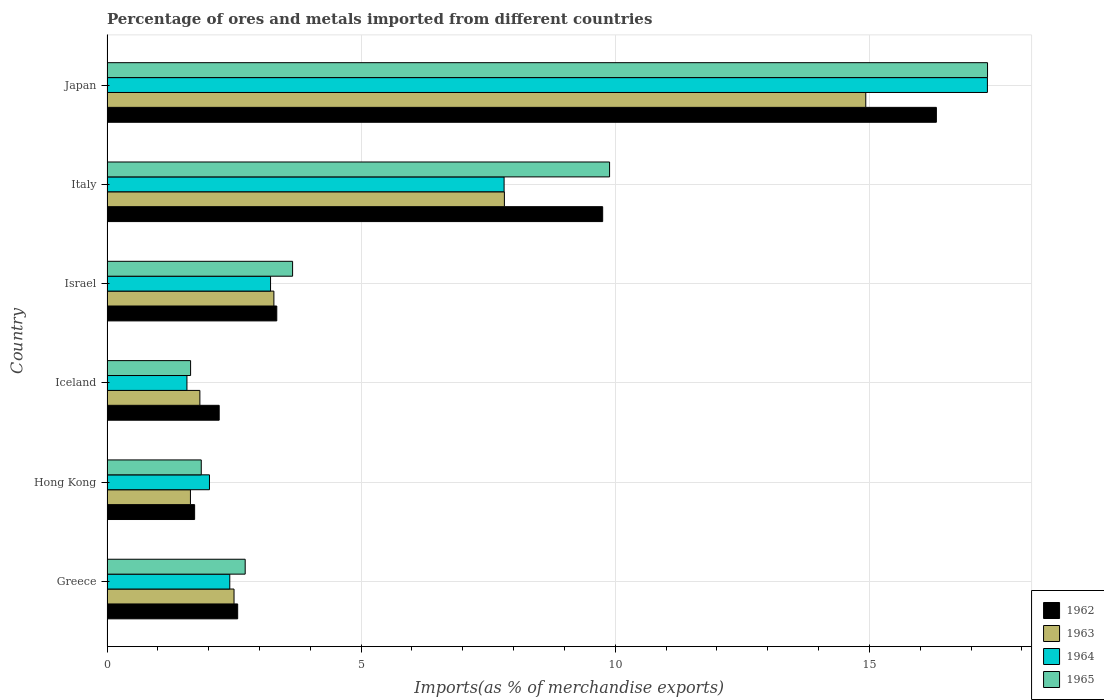Are the number of bars per tick equal to the number of legend labels?
Your answer should be compact. Yes. How many bars are there on the 3rd tick from the top?
Your response must be concise. 4. How many bars are there on the 1st tick from the bottom?
Offer a terse response. 4. What is the label of the 2nd group of bars from the top?
Your response must be concise. Italy. In how many cases, is the number of bars for a given country not equal to the number of legend labels?
Provide a succinct answer. 0. What is the percentage of imports to different countries in 1963 in Japan?
Your answer should be very brief. 14.93. Across all countries, what is the maximum percentage of imports to different countries in 1962?
Your response must be concise. 16.32. Across all countries, what is the minimum percentage of imports to different countries in 1962?
Your answer should be compact. 1.72. In which country was the percentage of imports to different countries in 1964 maximum?
Provide a succinct answer. Japan. In which country was the percentage of imports to different countries in 1965 minimum?
Keep it short and to the point. Iceland. What is the total percentage of imports to different countries in 1964 in the graph?
Your answer should be very brief. 34.35. What is the difference between the percentage of imports to different countries in 1965 in Greece and that in Iceland?
Your answer should be compact. 1.07. What is the difference between the percentage of imports to different countries in 1963 in Greece and the percentage of imports to different countries in 1965 in Hong Kong?
Your answer should be compact. 0.64. What is the average percentage of imports to different countries in 1962 per country?
Ensure brevity in your answer.  5.98. What is the difference between the percentage of imports to different countries in 1964 and percentage of imports to different countries in 1963 in Israel?
Offer a very short reply. -0.07. In how many countries, is the percentage of imports to different countries in 1965 greater than 13 %?
Ensure brevity in your answer.  1. What is the ratio of the percentage of imports to different countries in 1964 in Greece to that in Israel?
Ensure brevity in your answer.  0.75. Is the percentage of imports to different countries in 1962 in Israel less than that in Italy?
Your response must be concise. Yes. Is the difference between the percentage of imports to different countries in 1964 in Hong Kong and Japan greater than the difference between the percentage of imports to different countries in 1963 in Hong Kong and Japan?
Your response must be concise. No. What is the difference between the highest and the second highest percentage of imports to different countries in 1965?
Offer a terse response. 7.44. What is the difference between the highest and the lowest percentage of imports to different countries in 1963?
Offer a terse response. 13.29. In how many countries, is the percentage of imports to different countries in 1962 greater than the average percentage of imports to different countries in 1962 taken over all countries?
Offer a very short reply. 2. Is the sum of the percentage of imports to different countries in 1965 in Greece and Hong Kong greater than the maximum percentage of imports to different countries in 1962 across all countries?
Your response must be concise. No. What does the 1st bar from the top in Japan represents?
Ensure brevity in your answer.  1965. Is it the case that in every country, the sum of the percentage of imports to different countries in 1964 and percentage of imports to different countries in 1965 is greater than the percentage of imports to different countries in 1963?
Ensure brevity in your answer.  Yes. Are all the bars in the graph horizontal?
Your answer should be compact. Yes. How many countries are there in the graph?
Provide a succinct answer. 6. Are the values on the major ticks of X-axis written in scientific E-notation?
Make the answer very short. No. Does the graph contain any zero values?
Your answer should be very brief. No. Where does the legend appear in the graph?
Keep it short and to the point. Bottom right. How are the legend labels stacked?
Offer a very short reply. Vertical. What is the title of the graph?
Give a very brief answer. Percentage of ores and metals imported from different countries. What is the label or title of the X-axis?
Make the answer very short. Imports(as % of merchandise exports). What is the Imports(as % of merchandise exports) of 1962 in Greece?
Provide a succinct answer. 2.57. What is the Imports(as % of merchandise exports) in 1963 in Greece?
Your answer should be compact. 2.5. What is the Imports(as % of merchandise exports) in 1964 in Greece?
Make the answer very short. 2.42. What is the Imports(as % of merchandise exports) in 1965 in Greece?
Ensure brevity in your answer.  2.72. What is the Imports(as % of merchandise exports) in 1962 in Hong Kong?
Ensure brevity in your answer.  1.72. What is the Imports(as % of merchandise exports) in 1963 in Hong Kong?
Give a very brief answer. 1.64. What is the Imports(as % of merchandise exports) of 1964 in Hong Kong?
Your answer should be very brief. 2.02. What is the Imports(as % of merchandise exports) of 1965 in Hong Kong?
Keep it short and to the point. 1.85. What is the Imports(as % of merchandise exports) of 1962 in Iceland?
Your answer should be compact. 2.21. What is the Imports(as % of merchandise exports) of 1963 in Iceland?
Provide a short and direct response. 1.83. What is the Imports(as % of merchandise exports) in 1964 in Iceland?
Provide a succinct answer. 1.57. What is the Imports(as % of merchandise exports) in 1965 in Iceland?
Give a very brief answer. 1.64. What is the Imports(as % of merchandise exports) in 1962 in Israel?
Offer a terse response. 3.34. What is the Imports(as % of merchandise exports) in 1963 in Israel?
Your answer should be very brief. 3.28. What is the Imports(as % of merchandise exports) in 1964 in Israel?
Give a very brief answer. 3.22. What is the Imports(as % of merchandise exports) in 1965 in Israel?
Offer a terse response. 3.65. What is the Imports(as % of merchandise exports) in 1962 in Italy?
Your answer should be compact. 9.75. What is the Imports(as % of merchandise exports) in 1963 in Italy?
Keep it short and to the point. 7.82. What is the Imports(as % of merchandise exports) in 1964 in Italy?
Give a very brief answer. 7.81. What is the Imports(as % of merchandise exports) of 1965 in Italy?
Ensure brevity in your answer.  9.89. What is the Imports(as % of merchandise exports) in 1962 in Japan?
Give a very brief answer. 16.32. What is the Imports(as % of merchandise exports) of 1963 in Japan?
Ensure brevity in your answer.  14.93. What is the Imports(as % of merchandise exports) of 1964 in Japan?
Provide a succinct answer. 17.32. What is the Imports(as % of merchandise exports) in 1965 in Japan?
Your response must be concise. 17.32. Across all countries, what is the maximum Imports(as % of merchandise exports) of 1962?
Your response must be concise. 16.32. Across all countries, what is the maximum Imports(as % of merchandise exports) in 1963?
Offer a terse response. 14.93. Across all countries, what is the maximum Imports(as % of merchandise exports) in 1964?
Give a very brief answer. 17.32. Across all countries, what is the maximum Imports(as % of merchandise exports) of 1965?
Your answer should be compact. 17.32. Across all countries, what is the minimum Imports(as % of merchandise exports) of 1962?
Provide a short and direct response. 1.72. Across all countries, what is the minimum Imports(as % of merchandise exports) of 1963?
Keep it short and to the point. 1.64. Across all countries, what is the minimum Imports(as % of merchandise exports) of 1964?
Your answer should be compact. 1.57. Across all countries, what is the minimum Imports(as % of merchandise exports) in 1965?
Your answer should be compact. 1.64. What is the total Imports(as % of merchandise exports) of 1962 in the graph?
Give a very brief answer. 35.91. What is the total Imports(as % of merchandise exports) of 1963 in the graph?
Your answer should be very brief. 32. What is the total Imports(as % of merchandise exports) in 1964 in the graph?
Offer a very short reply. 34.35. What is the total Imports(as % of merchandise exports) of 1965 in the graph?
Provide a short and direct response. 37.08. What is the difference between the Imports(as % of merchandise exports) of 1962 in Greece and that in Hong Kong?
Give a very brief answer. 0.85. What is the difference between the Imports(as % of merchandise exports) in 1963 in Greece and that in Hong Kong?
Keep it short and to the point. 0.86. What is the difference between the Imports(as % of merchandise exports) of 1964 in Greece and that in Hong Kong?
Your answer should be compact. 0.4. What is the difference between the Imports(as % of merchandise exports) in 1965 in Greece and that in Hong Kong?
Your response must be concise. 0.86. What is the difference between the Imports(as % of merchandise exports) in 1962 in Greece and that in Iceland?
Give a very brief answer. 0.36. What is the difference between the Imports(as % of merchandise exports) of 1963 in Greece and that in Iceland?
Offer a very short reply. 0.67. What is the difference between the Imports(as % of merchandise exports) in 1964 in Greece and that in Iceland?
Provide a succinct answer. 0.84. What is the difference between the Imports(as % of merchandise exports) of 1965 in Greece and that in Iceland?
Your answer should be compact. 1.07. What is the difference between the Imports(as % of merchandise exports) of 1962 in Greece and that in Israel?
Offer a very short reply. -0.77. What is the difference between the Imports(as % of merchandise exports) of 1963 in Greece and that in Israel?
Offer a terse response. -0.78. What is the difference between the Imports(as % of merchandise exports) of 1964 in Greece and that in Israel?
Offer a very short reply. -0.8. What is the difference between the Imports(as % of merchandise exports) in 1965 in Greece and that in Israel?
Ensure brevity in your answer.  -0.93. What is the difference between the Imports(as % of merchandise exports) in 1962 in Greece and that in Italy?
Make the answer very short. -7.18. What is the difference between the Imports(as % of merchandise exports) of 1963 in Greece and that in Italy?
Offer a terse response. -5.32. What is the difference between the Imports(as % of merchandise exports) in 1964 in Greece and that in Italy?
Your answer should be compact. -5.4. What is the difference between the Imports(as % of merchandise exports) in 1965 in Greece and that in Italy?
Provide a succinct answer. -7.17. What is the difference between the Imports(as % of merchandise exports) of 1962 in Greece and that in Japan?
Give a very brief answer. -13.75. What is the difference between the Imports(as % of merchandise exports) in 1963 in Greece and that in Japan?
Your response must be concise. -12.43. What is the difference between the Imports(as % of merchandise exports) in 1964 in Greece and that in Japan?
Your answer should be compact. -14.9. What is the difference between the Imports(as % of merchandise exports) of 1965 in Greece and that in Japan?
Your answer should be compact. -14.6. What is the difference between the Imports(as % of merchandise exports) of 1962 in Hong Kong and that in Iceland?
Your answer should be compact. -0.48. What is the difference between the Imports(as % of merchandise exports) in 1963 in Hong Kong and that in Iceland?
Offer a very short reply. -0.19. What is the difference between the Imports(as % of merchandise exports) of 1964 in Hong Kong and that in Iceland?
Your response must be concise. 0.44. What is the difference between the Imports(as % of merchandise exports) in 1965 in Hong Kong and that in Iceland?
Your answer should be compact. 0.21. What is the difference between the Imports(as % of merchandise exports) of 1962 in Hong Kong and that in Israel?
Your response must be concise. -1.62. What is the difference between the Imports(as % of merchandise exports) of 1963 in Hong Kong and that in Israel?
Provide a succinct answer. -1.64. What is the difference between the Imports(as % of merchandise exports) of 1964 in Hong Kong and that in Israel?
Your answer should be compact. -1.2. What is the difference between the Imports(as % of merchandise exports) in 1965 in Hong Kong and that in Israel?
Make the answer very short. -1.8. What is the difference between the Imports(as % of merchandise exports) of 1962 in Hong Kong and that in Italy?
Keep it short and to the point. -8.03. What is the difference between the Imports(as % of merchandise exports) of 1963 in Hong Kong and that in Italy?
Provide a succinct answer. -6.18. What is the difference between the Imports(as % of merchandise exports) of 1964 in Hong Kong and that in Italy?
Your response must be concise. -5.8. What is the difference between the Imports(as % of merchandise exports) of 1965 in Hong Kong and that in Italy?
Ensure brevity in your answer.  -8.03. What is the difference between the Imports(as % of merchandise exports) in 1962 in Hong Kong and that in Japan?
Your response must be concise. -14.59. What is the difference between the Imports(as % of merchandise exports) in 1963 in Hong Kong and that in Japan?
Offer a terse response. -13.29. What is the difference between the Imports(as % of merchandise exports) of 1964 in Hong Kong and that in Japan?
Your answer should be very brief. -15.3. What is the difference between the Imports(as % of merchandise exports) of 1965 in Hong Kong and that in Japan?
Your answer should be compact. -15.47. What is the difference between the Imports(as % of merchandise exports) of 1962 in Iceland and that in Israel?
Give a very brief answer. -1.13. What is the difference between the Imports(as % of merchandise exports) in 1963 in Iceland and that in Israel?
Your response must be concise. -1.46. What is the difference between the Imports(as % of merchandise exports) of 1964 in Iceland and that in Israel?
Offer a very short reply. -1.65. What is the difference between the Imports(as % of merchandise exports) of 1965 in Iceland and that in Israel?
Give a very brief answer. -2.01. What is the difference between the Imports(as % of merchandise exports) of 1962 in Iceland and that in Italy?
Your response must be concise. -7.54. What is the difference between the Imports(as % of merchandise exports) of 1963 in Iceland and that in Italy?
Make the answer very short. -5.99. What is the difference between the Imports(as % of merchandise exports) in 1964 in Iceland and that in Italy?
Make the answer very short. -6.24. What is the difference between the Imports(as % of merchandise exports) in 1965 in Iceland and that in Italy?
Your response must be concise. -8.24. What is the difference between the Imports(as % of merchandise exports) in 1962 in Iceland and that in Japan?
Give a very brief answer. -14.11. What is the difference between the Imports(as % of merchandise exports) of 1963 in Iceland and that in Japan?
Provide a succinct answer. -13.1. What is the difference between the Imports(as % of merchandise exports) of 1964 in Iceland and that in Japan?
Your answer should be very brief. -15.75. What is the difference between the Imports(as % of merchandise exports) of 1965 in Iceland and that in Japan?
Make the answer very short. -15.68. What is the difference between the Imports(as % of merchandise exports) of 1962 in Israel and that in Italy?
Make the answer very short. -6.41. What is the difference between the Imports(as % of merchandise exports) in 1963 in Israel and that in Italy?
Your response must be concise. -4.53. What is the difference between the Imports(as % of merchandise exports) of 1964 in Israel and that in Italy?
Your response must be concise. -4.59. What is the difference between the Imports(as % of merchandise exports) of 1965 in Israel and that in Italy?
Keep it short and to the point. -6.24. What is the difference between the Imports(as % of merchandise exports) of 1962 in Israel and that in Japan?
Give a very brief answer. -12.98. What is the difference between the Imports(as % of merchandise exports) in 1963 in Israel and that in Japan?
Your answer should be very brief. -11.64. What is the difference between the Imports(as % of merchandise exports) in 1964 in Israel and that in Japan?
Your response must be concise. -14.1. What is the difference between the Imports(as % of merchandise exports) of 1965 in Israel and that in Japan?
Give a very brief answer. -13.67. What is the difference between the Imports(as % of merchandise exports) of 1962 in Italy and that in Japan?
Make the answer very short. -6.57. What is the difference between the Imports(as % of merchandise exports) in 1963 in Italy and that in Japan?
Make the answer very short. -7.11. What is the difference between the Imports(as % of merchandise exports) of 1964 in Italy and that in Japan?
Offer a very short reply. -9.51. What is the difference between the Imports(as % of merchandise exports) in 1965 in Italy and that in Japan?
Ensure brevity in your answer.  -7.44. What is the difference between the Imports(as % of merchandise exports) in 1962 in Greece and the Imports(as % of merchandise exports) in 1963 in Hong Kong?
Your answer should be compact. 0.93. What is the difference between the Imports(as % of merchandise exports) in 1962 in Greece and the Imports(as % of merchandise exports) in 1964 in Hong Kong?
Provide a short and direct response. 0.55. What is the difference between the Imports(as % of merchandise exports) in 1962 in Greece and the Imports(as % of merchandise exports) in 1965 in Hong Kong?
Offer a terse response. 0.72. What is the difference between the Imports(as % of merchandise exports) in 1963 in Greece and the Imports(as % of merchandise exports) in 1964 in Hong Kong?
Provide a succinct answer. 0.48. What is the difference between the Imports(as % of merchandise exports) in 1963 in Greece and the Imports(as % of merchandise exports) in 1965 in Hong Kong?
Offer a very short reply. 0.64. What is the difference between the Imports(as % of merchandise exports) in 1964 in Greece and the Imports(as % of merchandise exports) in 1965 in Hong Kong?
Offer a very short reply. 0.56. What is the difference between the Imports(as % of merchandise exports) in 1962 in Greece and the Imports(as % of merchandise exports) in 1963 in Iceland?
Provide a succinct answer. 0.74. What is the difference between the Imports(as % of merchandise exports) of 1962 in Greece and the Imports(as % of merchandise exports) of 1965 in Iceland?
Keep it short and to the point. 0.93. What is the difference between the Imports(as % of merchandise exports) in 1963 in Greece and the Imports(as % of merchandise exports) in 1964 in Iceland?
Provide a short and direct response. 0.93. What is the difference between the Imports(as % of merchandise exports) of 1963 in Greece and the Imports(as % of merchandise exports) of 1965 in Iceland?
Provide a succinct answer. 0.85. What is the difference between the Imports(as % of merchandise exports) of 1964 in Greece and the Imports(as % of merchandise exports) of 1965 in Iceland?
Offer a very short reply. 0.77. What is the difference between the Imports(as % of merchandise exports) of 1962 in Greece and the Imports(as % of merchandise exports) of 1963 in Israel?
Provide a short and direct response. -0.71. What is the difference between the Imports(as % of merchandise exports) of 1962 in Greece and the Imports(as % of merchandise exports) of 1964 in Israel?
Provide a succinct answer. -0.65. What is the difference between the Imports(as % of merchandise exports) in 1962 in Greece and the Imports(as % of merchandise exports) in 1965 in Israel?
Provide a succinct answer. -1.08. What is the difference between the Imports(as % of merchandise exports) of 1963 in Greece and the Imports(as % of merchandise exports) of 1964 in Israel?
Provide a short and direct response. -0.72. What is the difference between the Imports(as % of merchandise exports) of 1963 in Greece and the Imports(as % of merchandise exports) of 1965 in Israel?
Provide a short and direct response. -1.15. What is the difference between the Imports(as % of merchandise exports) of 1964 in Greece and the Imports(as % of merchandise exports) of 1965 in Israel?
Your answer should be very brief. -1.24. What is the difference between the Imports(as % of merchandise exports) of 1962 in Greece and the Imports(as % of merchandise exports) of 1963 in Italy?
Make the answer very short. -5.25. What is the difference between the Imports(as % of merchandise exports) of 1962 in Greece and the Imports(as % of merchandise exports) of 1964 in Italy?
Your answer should be very brief. -5.24. What is the difference between the Imports(as % of merchandise exports) in 1962 in Greece and the Imports(as % of merchandise exports) in 1965 in Italy?
Give a very brief answer. -7.32. What is the difference between the Imports(as % of merchandise exports) in 1963 in Greece and the Imports(as % of merchandise exports) in 1964 in Italy?
Keep it short and to the point. -5.31. What is the difference between the Imports(as % of merchandise exports) of 1963 in Greece and the Imports(as % of merchandise exports) of 1965 in Italy?
Keep it short and to the point. -7.39. What is the difference between the Imports(as % of merchandise exports) in 1964 in Greece and the Imports(as % of merchandise exports) in 1965 in Italy?
Ensure brevity in your answer.  -7.47. What is the difference between the Imports(as % of merchandise exports) in 1962 in Greece and the Imports(as % of merchandise exports) in 1963 in Japan?
Provide a succinct answer. -12.36. What is the difference between the Imports(as % of merchandise exports) in 1962 in Greece and the Imports(as % of merchandise exports) in 1964 in Japan?
Provide a short and direct response. -14.75. What is the difference between the Imports(as % of merchandise exports) of 1962 in Greece and the Imports(as % of merchandise exports) of 1965 in Japan?
Keep it short and to the point. -14.75. What is the difference between the Imports(as % of merchandise exports) of 1963 in Greece and the Imports(as % of merchandise exports) of 1964 in Japan?
Make the answer very short. -14.82. What is the difference between the Imports(as % of merchandise exports) of 1963 in Greece and the Imports(as % of merchandise exports) of 1965 in Japan?
Make the answer very short. -14.82. What is the difference between the Imports(as % of merchandise exports) in 1964 in Greece and the Imports(as % of merchandise exports) in 1965 in Japan?
Keep it short and to the point. -14.91. What is the difference between the Imports(as % of merchandise exports) of 1962 in Hong Kong and the Imports(as % of merchandise exports) of 1963 in Iceland?
Your answer should be very brief. -0.1. What is the difference between the Imports(as % of merchandise exports) of 1962 in Hong Kong and the Imports(as % of merchandise exports) of 1964 in Iceland?
Your answer should be compact. 0.15. What is the difference between the Imports(as % of merchandise exports) in 1962 in Hong Kong and the Imports(as % of merchandise exports) in 1965 in Iceland?
Ensure brevity in your answer.  0.08. What is the difference between the Imports(as % of merchandise exports) of 1963 in Hong Kong and the Imports(as % of merchandise exports) of 1964 in Iceland?
Your response must be concise. 0.07. What is the difference between the Imports(as % of merchandise exports) in 1963 in Hong Kong and the Imports(as % of merchandise exports) in 1965 in Iceland?
Offer a terse response. -0. What is the difference between the Imports(as % of merchandise exports) in 1964 in Hong Kong and the Imports(as % of merchandise exports) in 1965 in Iceland?
Ensure brevity in your answer.  0.37. What is the difference between the Imports(as % of merchandise exports) in 1962 in Hong Kong and the Imports(as % of merchandise exports) in 1963 in Israel?
Provide a short and direct response. -1.56. What is the difference between the Imports(as % of merchandise exports) of 1962 in Hong Kong and the Imports(as % of merchandise exports) of 1964 in Israel?
Offer a very short reply. -1.49. What is the difference between the Imports(as % of merchandise exports) of 1962 in Hong Kong and the Imports(as % of merchandise exports) of 1965 in Israel?
Make the answer very short. -1.93. What is the difference between the Imports(as % of merchandise exports) of 1963 in Hong Kong and the Imports(as % of merchandise exports) of 1964 in Israel?
Provide a succinct answer. -1.58. What is the difference between the Imports(as % of merchandise exports) of 1963 in Hong Kong and the Imports(as % of merchandise exports) of 1965 in Israel?
Offer a very short reply. -2.01. What is the difference between the Imports(as % of merchandise exports) in 1964 in Hong Kong and the Imports(as % of merchandise exports) in 1965 in Israel?
Your response must be concise. -1.64. What is the difference between the Imports(as % of merchandise exports) of 1962 in Hong Kong and the Imports(as % of merchandise exports) of 1963 in Italy?
Provide a short and direct response. -6.09. What is the difference between the Imports(as % of merchandise exports) in 1962 in Hong Kong and the Imports(as % of merchandise exports) in 1964 in Italy?
Your answer should be compact. -6.09. What is the difference between the Imports(as % of merchandise exports) of 1962 in Hong Kong and the Imports(as % of merchandise exports) of 1965 in Italy?
Your response must be concise. -8.16. What is the difference between the Imports(as % of merchandise exports) of 1963 in Hong Kong and the Imports(as % of merchandise exports) of 1964 in Italy?
Your answer should be compact. -6.17. What is the difference between the Imports(as % of merchandise exports) of 1963 in Hong Kong and the Imports(as % of merchandise exports) of 1965 in Italy?
Provide a succinct answer. -8.25. What is the difference between the Imports(as % of merchandise exports) in 1964 in Hong Kong and the Imports(as % of merchandise exports) in 1965 in Italy?
Your answer should be compact. -7.87. What is the difference between the Imports(as % of merchandise exports) of 1962 in Hong Kong and the Imports(as % of merchandise exports) of 1963 in Japan?
Provide a succinct answer. -13.2. What is the difference between the Imports(as % of merchandise exports) of 1962 in Hong Kong and the Imports(as % of merchandise exports) of 1964 in Japan?
Give a very brief answer. -15.6. What is the difference between the Imports(as % of merchandise exports) of 1962 in Hong Kong and the Imports(as % of merchandise exports) of 1965 in Japan?
Give a very brief answer. -15.6. What is the difference between the Imports(as % of merchandise exports) of 1963 in Hong Kong and the Imports(as % of merchandise exports) of 1964 in Japan?
Your response must be concise. -15.68. What is the difference between the Imports(as % of merchandise exports) of 1963 in Hong Kong and the Imports(as % of merchandise exports) of 1965 in Japan?
Your answer should be very brief. -15.68. What is the difference between the Imports(as % of merchandise exports) of 1964 in Hong Kong and the Imports(as % of merchandise exports) of 1965 in Japan?
Your answer should be very brief. -15.31. What is the difference between the Imports(as % of merchandise exports) of 1962 in Iceland and the Imports(as % of merchandise exports) of 1963 in Israel?
Your answer should be compact. -1.08. What is the difference between the Imports(as % of merchandise exports) of 1962 in Iceland and the Imports(as % of merchandise exports) of 1964 in Israel?
Your answer should be very brief. -1.01. What is the difference between the Imports(as % of merchandise exports) of 1962 in Iceland and the Imports(as % of merchandise exports) of 1965 in Israel?
Make the answer very short. -1.44. What is the difference between the Imports(as % of merchandise exports) in 1963 in Iceland and the Imports(as % of merchandise exports) in 1964 in Israel?
Your response must be concise. -1.39. What is the difference between the Imports(as % of merchandise exports) of 1963 in Iceland and the Imports(as % of merchandise exports) of 1965 in Israel?
Keep it short and to the point. -1.82. What is the difference between the Imports(as % of merchandise exports) in 1964 in Iceland and the Imports(as % of merchandise exports) in 1965 in Israel?
Ensure brevity in your answer.  -2.08. What is the difference between the Imports(as % of merchandise exports) in 1962 in Iceland and the Imports(as % of merchandise exports) in 1963 in Italy?
Offer a very short reply. -5.61. What is the difference between the Imports(as % of merchandise exports) in 1962 in Iceland and the Imports(as % of merchandise exports) in 1964 in Italy?
Provide a succinct answer. -5.61. What is the difference between the Imports(as % of merchandise exports) in 1962 in Iceland and the Imports(as % of merchandise exports) in 1965 in Italy?
Provide a short and direct response. -7.68. What is the difference between the Imports(as % of merchandise exports) of 1963 in Iceland and the Imports(as % of merchandise exports) of 1964 in Italy?
Your response must be concise. -5.98. What is the difference between the Imports(as % of merchandise exports) in 1963 in Iceland and the Imports(as % of merchandise exports) in 1965 in Italy?
Keep it short and to the point. -8.06. What is the difference between the Imports(as % of merchandise exports) of 1964 in Iceland and the Imports(as % of merchandise exports) of 1965 in Italy?
Your answer should be very brief. -8.31. What is the difference between the Imports(as % of merchandise exports) of 1962 in Iceland and the Imports(as % of merchandise exports) of 1963 in Japan?
Give a very brief answer. -12.72. What is the difference between the Imports(as % of merchandise exports) of 1962 in Iceland and the Imports(as % of merchandise exports) of 1964 in Japan?
Your answer should be very brief. -15.11. What is the difference between the Imports(as % of merchandise exports) of 1962 in Iceland and the Imports(as % of merchandise exports) of 1965 in Japan?
Your answer should be compact. -15.12. What is the difference between the Imports(as % of merchandise exports) in 1963 in Iceland and the Imports(as % of merchandise exports) in 1964 in Japan?
Offer a very short reply. -15.49. What is the difference between the Imports(as % of merchandise exports) in 1963 in Iceland and the Imports(as % of merchandise exports) in 1965 in Japan?
Your answer should be very brief. -15.5. What is the difference between the Imports(as % of merchandise exports) of 1964 in Iceland and the Imports(as % of merchandise exports) of 1965 in Japan?
Ensure brevity in your answer.  -15.75. What is the difference between the Imports(as % of merchandise exports) in 1962 in Israel and the Imports(as % of merchandise exports) in 1963 in Italy?
Make the answer very short. -4.48. What is the difference between the Imports(as % of merchandise exports) in 1962 in Israel and the Imports(as % of merchandise exports) in 1964 in Italy?
Give a very brief answer. -4.47. What is the difference between the Imports(as % of merchandise exports) of 1962 in Israel and the Imports(as % of merchandise exports) of 1965 in Italy?
Provide a short and direct response. -6.55. What is the difference between the Imports(as % of merchandise exports) in 1963 in Israel and the Imports(as % of merchandise exports) in 1964 in Italy?
Give a very brief answer. -4.53. What is the difference between the Imports(as % of merchandise exports) of 1963 in Israel and the Imports(as % of merchandise exports) of 1965 in Italy?
Offer a terse response. -6.6. What is the difference between the Imports(as % of merchandise exports) of 1964 in Israel and the Imports(as % of merchandise exports) of 1965 in Italy?
Your answer should be compact. -6.67. What is the difference between the Imports(as % of merchandise exports) of 1962 in Israel and the Imports(as % of merchandise exports) of 1963 in Japan?
Offer a very short reply. -11.59. What is the difference between the Imports(as % of merchandise exports) of 1962 in Israel and the Imports(as % of merchandise exports) of 1964 in Japan?
Ensure brevity in your answer.  -13.98. What is the difference between the Imports(as % of merchandise exports) of 1962 in Israel and the Imports(as % of merchandise exports) of 1965 in Japan?
Provide a short and direct response. -13.98. What is the difference between the Imports(as % of merchandise exports) in 1963 in Israel and the Imports(as % of merchandise exports) in 1964 in Japan?
Your answer should be compact. -14.04. What is the difference between the Imports(as % of merchandise exports) in 1963 in Israel and the Imports(as % of merchandise exports) in 1965 in Japan?
Offer a very short reply. -14.04. What is the difference between the Imports(as % of merchandise exports) of 1964 in Israel and the Imports(as % of merchandise exports) of 1965 in Japan?
Keep it short and to the point. -14.11. What is the difference between the Imports(as % of merchandise exports) in 1962 in Italy and the Imports(as % of merchandise exports) in 1963 in Japan?
Your answer should be compact. -5.18. What is the difference between the Imports(as % of merchandise exports) in 1962 in Italy and the Imports(as % of merchandise exports) in 1964 in Japan?
Your answer should be compact. -7.57. What is the difference between the Imports(as % of merchandise exports) in 1962 in Italy and the Imports(as % of merchandise exports) in 1965 in Japan?
Your response must be concise. -7.57. What is the difference between the Imports(as % of merchandise exports) of 1963 in Italy and the Imports(as % of merchandise exports) of 1964 in Japan?
Keep it short and to the point. -9.5. What is the difference between the Imports(as % of merchandise exports) in 1963 in Italy and the Imports(as % of merchandise exports) in 1965 in Japan?
Make the answer very short. -9.51. What is the difference between the Imports(as % of merchandise exports) of 1964 in Italy and the Imports(as % of merchandise exports) of 1965 in Japan?
Give a very brief answer. -9.51. What is the average Imports(as % of merchandise exports) of 1962 per country?
Give a very brief answer. 5.98. What is the average Imports(as % of merchandise exports) of 1963 per country?
Provide a succinct answer. 5.33. What is the average Imports(as % of merchandise exports) of 1964 per country?
Your response must be concise. 5.73. What is the average Imports(as % of merchandise exports) of 1965 per country?
Provide a succinct answer. 6.18. What is the difference between the Imports(as % of merchandise exports) of 1962 and Imports(as % of merchandise exports) of 1963 in Greece?
Ensure brevity in your answer.  0.07. What is the difference between the Imports(as % of merchandise exports) in 1962 and Imports(as % of merchandise exports) in 1964 in Greece?
Offer a very short reply. 0.16. What is the difference between the Imports(as % of merchandise exports) in 1962 and Imports(as % of merchandise exports) in 1965 in Greece?
Ensure brevity in your answer.  -0.15. What is the difference between the Imports(as % of merchandise exports) in 1963 and Imports(as % of merchandise exports) in 1964 in Greece?
Your answer should be compact. 0.08. What is the difference between the Imports(as % of merchandise exports) in 1963 and Imports(as % of merchandise exports) in 1965 in Greece?
Your response must be concise. -0.22. What is the difference between the Imports(as % of merchandise exports) of 1964 and Imports(as % of merchandise exports) of 1965 in Greece?
Your response must be concise. -0.3. What is the difference between the Imports(as % of merchandise exports) in 1962 and Imports(as % of merchandise exports) in 1963 in Hong Kong?
Offer a terse response. 0.08. What is the difference between the Imports(as % of merchandise exports) in 1962 and Imports(as % of merchandise exports) in 1964 in Hong Kong?
Make the answer very short. -0.29. What is the difference between the Imports(as % of merchandise exports) in 1962 and Imports(as % of merchandise exports) in 1965 in Hong Kong?
Offer a very short reply. -0.13. What is the difference between the Imports(as % of merchandise exports) in 1963 and Imports(as % of merchandise exports) in 1964 in Hong Kong?
Provide a short and direct response. -0.37. What is the difference between the Imports(as % of merchandise exports) in 1963 and Imports(as % of merchandise exports) in 1965 in Hong Kong?
Your response must be concise. -0.21. What is the difference between the Imports(as % of merchandise exports) of 1964 and Imports(as % of merchandise exports) of 1965 in Hong Kong?
Give a very brief answer. 0.16. What is the difference between the Imports(as % of merchandise exports) of 1962 and Imports(as % of merchandise exports) of 1963 in Iceland?
Give a very brief answer. 0.38. What is the difference between the Imports(as % of merchandise exports) of 1962 and Imports(as % of merchandise exports) of 1964 in Iceland?
Keep it short and to the point. 0.63. What is the difference between the Imports(as % of merchandise exports) of 1962 and Imports(as % of merchandise exports) of 1965 in Iceland?
Your answer should be compact. 0.56. What is the difference between the Imports(as % of merchandise exports) of 1963 and Imports(as % of merchandise exports) of 1964 in Iceland?
Offer a terse response. 0.25. What is the difference between the Imports(as % of merchandise exports) of 1963 and Imports(as % of merchandise exports) of 1965 in Iceland?
Ensure brevity in your answer.  0.18. What is the difference between the Imports(as % of merchandise exports) in 1964 and Imports(as % of merchandise exports) in 1965 in Iceland?
Your answer should be compact. -0.07. What is the difference between the Imports(as % of merchandise exports) in 1962 and Imports(as % of merchandise exports) in 1963 in Israel?
Keep it short and to the point. 0.06. What is the difference between the Imports(as % of merchandise exports) in 1962 and Imports(as % of merchandise exports) in 1964 in Israel?
Ensure brevity in your answer.  0.12. What is the difference between the Imports(as % of merchandise exports) in 1962 and Imports(as % of merchandise exports) in 1965 in Israel?
Give a very brief answer. -0.31. What is the difference between the Imports(as % of merchandise exports) of 1963 and Imports(as % of merchandise exports) of 1964 in Israel?
Give a very brief answer. 0.07. What is the difference between the Imports(as % of merchandise exports) in 1963 and Imports(as % of merchandise exports) in 1965 in Israel?
Your answer should be compact. -0.37. What is the difference between the Imports(as % of merchandise exports) of 1964 and Imports(as % of merchandise exports) of 1965 in Israel?
Offer a very short reply. -0.43. What is the difference between the Imports(as % of merchandise exports) of 1962 and Imports(as % of merchandise exports) of 1963 in Italy?
Ensure brevity in your answer.  1.93. What is the difference between the Imports(as % of merchandise exports) in 1962 and Imports(as % of merchandise exports) in 1964 in Italy?
Offer a terse response. 1.94. What is the difference between the Imports(as % of merchandise exports) of 1962 and Imports(as % of merchandise exports) of 1965 in Italy?
Keep it short and to the point. -0.14. What is the difference between the Imports(as % of merchandise exports) of 1963 and Imports(as % of merchandise exports) of 1964 in Italy?
Ensure brevity in your answer.  0.01. What is the difference between the Imports(as % of merchandise exports) of 1963 and Imports(as % of merchandise exports) of 1965 in Italy?
Your response must be concise. -2.07. What is the difference between the Imports(as % of merchandise exports) in 1964 and Imports(as % of merchandise exports) in 1965 in Italy?
Provide a short and direct response. -2.08. What is the difference between the Imports(as % of merchandise exports) in 1962 and Imports(as % of merchandise exports) in 1963 in Japan?
Your response must be concise. 1.39. What is the difference between the Imports(as % of merchandise exports) in 1962 and Imports(as % of merchandise exports) in 1964 in Japan?
Ensure brevity in your answer.  -1. What is the difference between the Imports(as % of merchandise exports) of 1962 and Imports(as % of merchandise exports) of 1965 in Japan?
Make the answer very short. -1.01. What is the difference between the Imports(as % of merchandise exports) in 1963 and Imports(as % of merchandise exports) in 1964 in Japan?
Ensure brevity in your answer.  -2.39. What is the difference between the Imports(as % of merchandise exports) of 1963 and Imports(as % of merchandise exports) of 1965 in Japan?
Make the answer very short. -2.4. What is the difference between the Imports(as % of merchandise exports) of 1964 and Imports(as % of merchandise exports) of 1965 in Japan?
Your answer should be compact. -0. What is the ratio of the Imports(as % of merchandise exports) of 1962 in Greece to that in Hong Kong?
Offer a terse response. 1.49. What is the ratio of the Imports(as % of merchandise exports) in 1963 in Greece to that in Hong Kong?
Offer a terse response. 1.52. What is the ratio of the Imports(as % of merchandise exports) in 1964 in Greece to that in Hong Kong?
Your response must be concise. 1.2. What is the ratio of the Imports(as % of merchandise exports) of 1965 in Greece to that in Hong Kong?
Your answer should be very brief. 1.47. What is the ratio of the Imports(as % of merchandise exports) in 1962 in Greece to that in Iceland?
Ensure brevity in your answer.  1.16. What is the ratio of the Imports(as % of merchandise exports) in 1963 in Greece to that in Iceland?
Your answer should be very brief. 1.37. What is the ratio of the Imports(as % of merchandise exports) of 1964 in Greece to that in Iceland?
Your response must be concise. 1.54. What is the ratio of the Imports(as % of merchandise exports) in 1965 in Greece to that in Iceland?
Provide a short and direct response. 1.65. What is the ratio of the Imports(as % of merchandise exports) in 1962 in Greece to that in Israel?
Give a very brief answer. 0.77. What is the ratio of the Imports(as % of merchandise exports) in 1963 in Greece to that in Israel?
Your response must be concise. 0.76. What is the ratio of the Imports(as % of merchandise exports) in 1964 in Greece to that in Israel?
Provide a succinct answer. 0.75. What is the ratio of the Imports(as % of merchandise exports) in 1965 in Greece to that in Israel?
Provide a succinct answer. 0.74. What is the ratio of the Imports(as % of merchandise exports) in 1962 in Greece to that in Italy?
Give a very brief answer. 0.26. What is the ratio of the Imports(as % of merchandise exports) of 1963 in Greece to that in Italy?
Give a very brief answer. 0.32. What is the ratio of the Imports(as % of merchandise exports) of 1964 in Greece to that in Italy?
Provide a short and direct response. 0.31. What is the ratio of the Imports(as % of merchandise exports) in 1965 in Greece to that in Italy?
Your answer should be compact. 0.28. What is the ratio of the Imports(as % of merchandise exports) of 1962 in Greece to that in Japan?
Provide a succinct answer. 0.16. What is the ratio of the Imports(as % of merchandise exports) of 1963 in Greece to that in Japan?
Your answer should be compact. 0.17. What is the ratio of the Imports(as % of merchandise exports) of 1964 in Greece to that in Japan?
Give a very brief answer. 0.14. What is the ratio of the Imports(as % of merchandise exports) in 1965 in Greece to that in Japan?
Ensure brevity in your answer.  0.16. What is the ratio of the Imports(as % of merchandise exports) of 1962 in Hong Kong to that in Iceland?
Your response must be concise. 0.78. What is the ratio of the Imports(as % of merchandise exports) of 1963 in Hong Kong to that in Iceland?
Make the answer very short. 0.9. What is the ratio of the Imports(as % of merchandise exports) of 1964 in Hong Kong to that in Iceland?
Provide a short and direct response. 1.28. What is the ratio of the Imports(as % of merchandise exports) in 1965 in Hong Kong to that in Iceland?
Offer a very short reply. 1.13. What is the ratio of the Imports(as % of merchandise exports) of 1962 in Hong Kong to that in Israel?
Offer a very short reply. 0.52. What is the ratio of the Imports(as % of merchandise exports) in 1963 in Hong Kong to that in Israel?
Offer a very short reply. 0.5. What is the ratio of the Imports(as % of merchandise exports) in 1964 in Hong Kong to that in Israel?
Ensure brevity in your answer.  0.63. What is the ratio of the Imports(as % of merchandise exports) in 1965 in Hong Kong to that in Israel?
Give a very brief answer. 0.51. What is the ratio of the Imports(as % of merchandise exports) in 1962 in Hong Kong to that in Italy?
Provide a succinct answer. 0.18. What is the ratio of the Imports(as % of merchandise exports) of 1963 in Hong Kong to that in Italy?
Offer a very short reply. 0.21. What is the ratio of the Imports(as % of merchandise exports) in 1964 in Hong Kong to that in Italy?
Your answer should be very brief. 0.26. What is the ratio of the Imports(as % of merchandise exports) in 1965 in Hong Kong to that in Italy?
Offer a terse response. 0.19. What is the ratio of the Imports(as % of merchandise exports) in 1962 in Hong Kong to that in Japan?
Provide a short and direct response. 0.11. What is the ratio of the Imports(as % of merchandise exports) in 1963 in Hong Kong to that in Japan?
Provide a succinct answer. 0.11. What is the ratio of the Imports(as % of merchandise exports) in 1964 in Hong Kong to that in Japan?
Give a very brief answer. 0.12. What is the ratio of the Imports(as % of merchandise exports) in 1965 in Hong Kong to that in Japan?
Provide a short and direct response. 0.11. What is the ratio of the Imports(as % of merchandise exports) of 1962 in Iceland to that in Israel?
Make the answer very short. 0.66. What is the ratio of the Imports(as % of merchandise exports) in 1963 in Iceland to that in Israel?
Your response must be concise. 0.56. What is the ratio of the Imports(as % of merchandise exports) in 1964 in Iceland to that in Israel?
Provide a succinct answer. 0.49. What is the ratio of the Imports(as % of merchandise exports) in 1965 in Iceland to that in Israel?
Keep it short and to the point. 0.45. What is the ratio of the Imports(as % of merchandise exports) of 1962 in Iceland to that in Italy?
Offer a very short reply. 0.23. What is the ratio of the Imports(as % of merchandise exports) in 1963 in Iceland to that in Italy?
Offer a terse response. 0.23. What is the ratio of the Imports(as % of merchandise exports) of 1964 in Iceland to that in Italy?
Make the answer very short. 0.2. What is the ratio of the Imports(as % of merchandise exports) of 1965 in Iceland to that in Italy?
Offer a very short reply. 0.17. What is the ratio of the Imports(as % of merchandise exports) in 1962 in Iceland to that in Japan?
Your answer should be very brief. 0.14. What is the ratio of the Imports(as % of merchandise exports) in 1963 in Iceland to that in Japan?
Keep it short and to the point. 0.12. What is the ratio of the Imports(as % of merchandise exports) in 1964 in Iceland to that in Japan?
Provide a succinct answer. 0.09. What is the ratio of the Imports(as % of merchandise exports) of 1965 in Iceland to that in Japan?
Offer a terse response. 0.09. What is the ratio of the Imports(as % of merchandise exports) of 1962 in Israel to that in Italy?
Make the answer very short. 0.34. What is the ratio of the Imports(as % of merchandise exports) of 1963 in Israel to that in Italy?
Provide a short and direct response. 0.42. What is the ratio of the Imports(as % of merchandise exports) in 1964 in Israel to that in Italy?
Give a very brief answer. 0.41. What is the ratio of the Imports(as % of merchandise exports) of 1965 in Israel to that in Italy?
Your response must be concise. 0.37. What is the ratio of the Imports(as % of merchandise exports) of 1962 in Israel to that in Japan?
Give a very brief answer. 0.2. What is the ratio of the Imports(as % of merchandise exports) of 1963 in Israel to that in Japan?
Ensure brevity in your answer.  0.22. What is the ratio of the Imports(as % of merchandise exports) in 1964 in Israel to that in Japan?
Make the answer very short. 0.19. What is the ratio of the Imports(as % of merchandise exports) of 1965 in Israel to that in Japan?
Offer a very short reply. 0.21. What is the ratio of the Imports(as % of merchandise exports) in 1962 in Italy to that in Japan?
Give a very brief answer. 0.6. What is the ratio of the Imports(as % of merchandise exports) in 1963 in Italy to that in Japan?
Make the answer very short. 0.52. What is the ratio of the Imports(as % of merchandise exports) in 1964 in Italy to that in Japan?
Make the answer very short. 0.45. What is the ratio of the Imports(as % of merchandise exports) of 1965 in Italy to that in Japan?
Offer a very short reply. 0.57. What is the difference between the highest and the second highest Imports(as % of merchandise exports) of 1962?
Offer a terse response. 6.57. What is the difference between the highest and the second highest Imports(as % of merchandise exports) in 1963?
Your response must be concise. 7.11. What is the difference between the highest and the second highest Imports(as % of merchandise exports) in 1964?
Offer a terse response. 9.51. What is the difference between the highest and the second highest Imports(as % of merchandise exports) in 1965?
Make the answer very short. 7.44. What is the difference between the highest and the lowest Imports(as % of merchandise exports) in 1962?
Offer a terse response. 14.59. What is the difference between the highest and the lowest Imports(as % of merchandise exports) of 1963?
Ensure brevity in your answer.  13.29. What is the difference between the highest and the lowest Imports(as % of merchandise exports) of 1964?
Your response must be concise. 15.75. What is the difference between the highest and the lowest Imports(as % of merchandise exports) in 1965?
Provide a short and direct response. 15.68. 